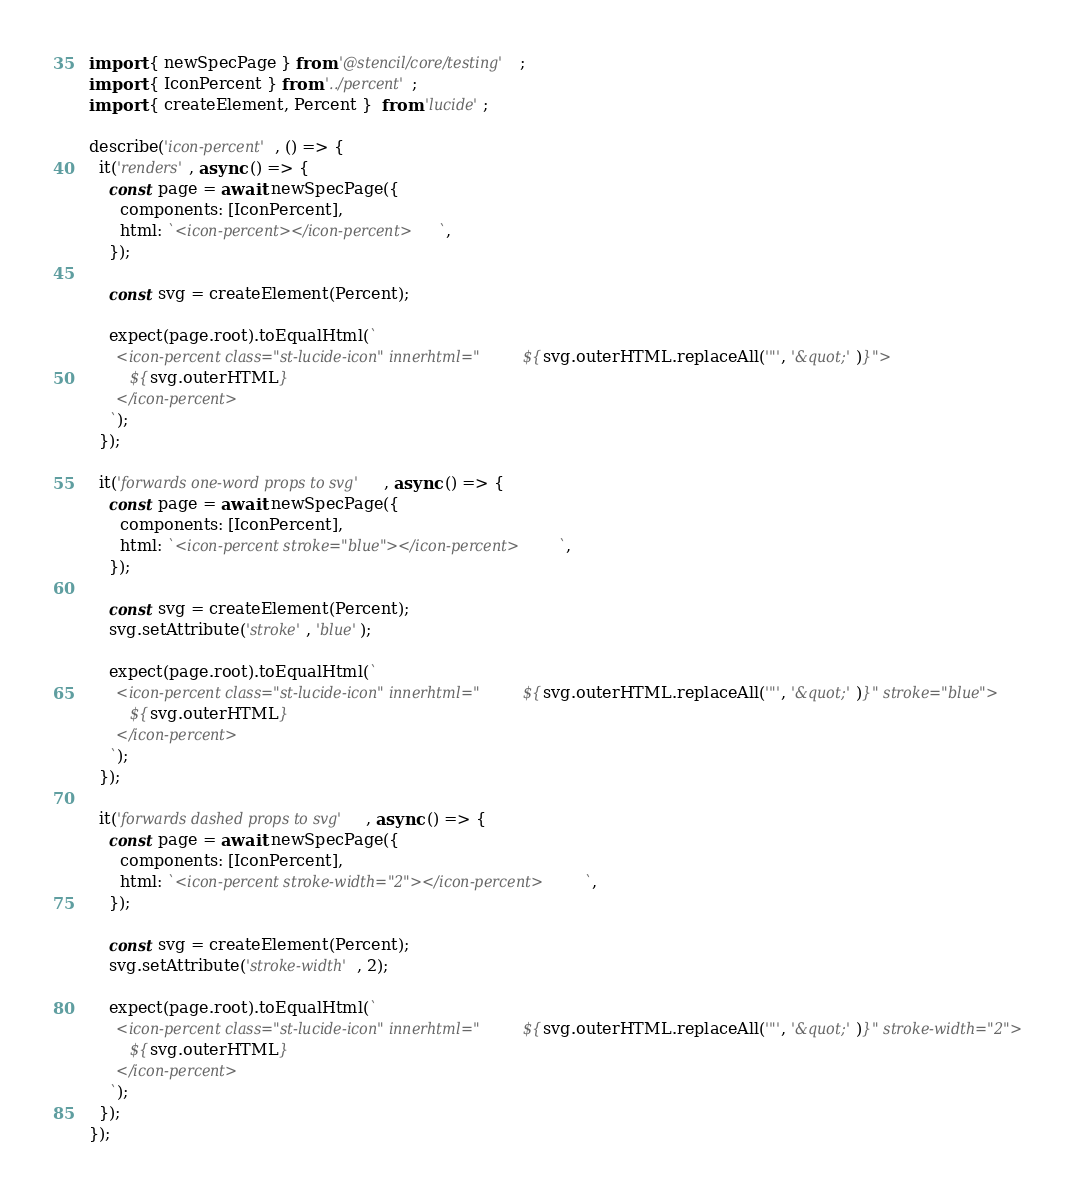Convert code to text. <code><loc_0><loc_0><loc_500><loc_500><_TypeScript_>import { newSpecPage } from '@stencil/core/testing';
import { IconPercent } from '../percent';
import { createElement, Percent }  from 'lucide';

describe('icon-percent', () => {
  it('renders', async () => {
    const page = await newSpecPage({
      components: [IconPercent],
      html: `<icon-percent></icon-percent>`,
    });

    const svg = createElement(Percent);

    expect(page.root).toEqualHtml(`
      <icon-percent class="st-lucide-icon" innerhtml="${svg.outerHTML.replaceAll('"', '&quot;')}">
        ${svg.outerHTML}
      </icon-percent>
    `);
  });

  it('forwards one-word props to svg', async () => {
    const page = await newSpecPage({
      components: [IconPercent],
      html: `<icon-percent stroke="blue"></icon-percent>`,
    });

    const svg = createElement(Percent);
    svg.setAttribute('stroke', 'blue');

    expect(page.root).toEqualHtml(`
      <icon-percent class="st-lucide-icon" innerhtml="${svg.outerHTML.replaceAll('"', '&quot;')}" stroke="blue">
        ${svg.outerHTML}
      </icon-percent>
    `);
  });

  it('forwards dashed props to svg', async () => {
    const page = await newSpecPage({
      components: [IconPercent],
      html: `<icon-percent stroke-width="2"></icon-percent>`,
    });

    const svg = createElement(Percent);
    svg.setAttribute('stroke-width', 2);

    expect(page.root).toEqualHtml(`
      <icon-percent class="st-lucide-icon" innerhtml="${svg.outerHTML.replaceAll('"', '&quot;')}" stroke-width="2">
        ${svg.outerHTML}
      </icon-percent>
    `);
  });
});
</code> 